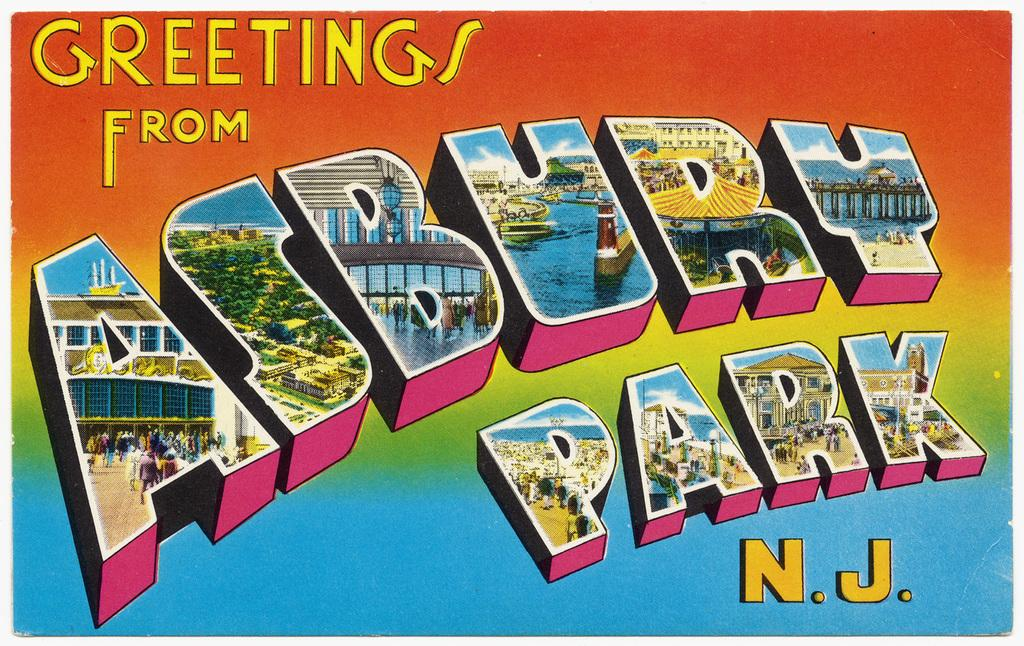<image>
Summarize the visual content of the image. A greeting card from the Asbury Park with different colors and the letters with parts of the landscape of the park. 